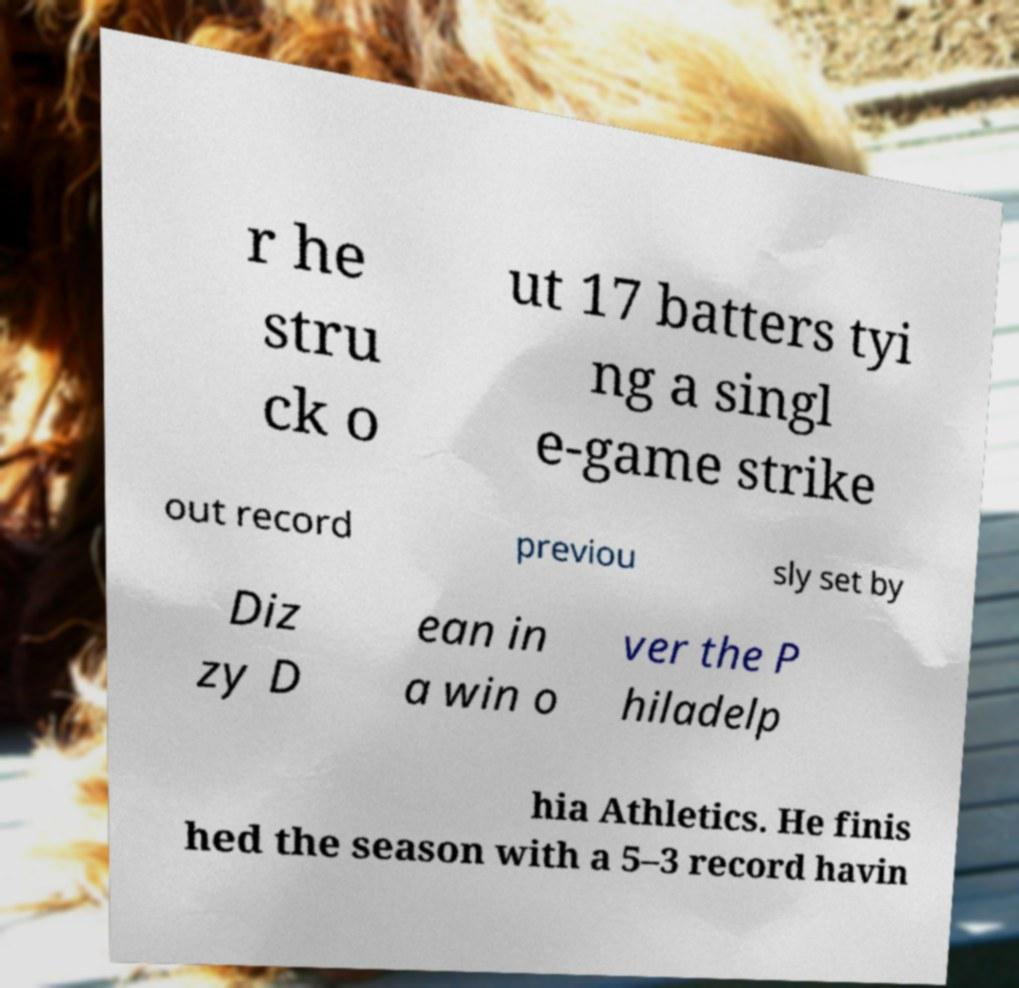Could you assist in decoding the text presented in this image and type it out clearly? r he stru ck o ut 17 batters tyi ng a singl e-game strike out record previou sly set by Diz zy D ean in a win o ver the P hiladelp hia Athletics. He finis hed the season with a 5–3 record havin 